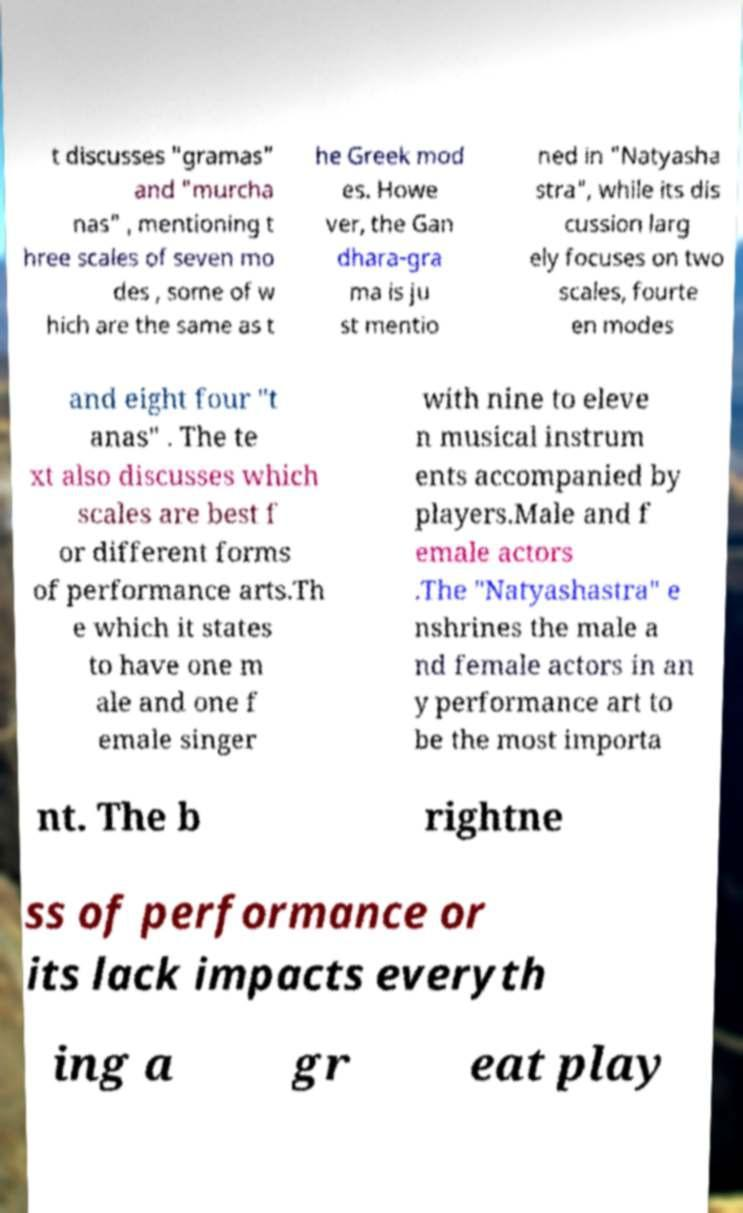Please read and relay the text visible in this image. What does it say? t discusses "gramas" and "murcha nas" , mentioning t hree scales of seven mo des , some of w hich are the same as t he Greek mod es. Howe ver, the Gan dhara-gra ma is ju st mentio ned in "Natyasha stra", while its dis cussion larg ely focuses on two scales, fourte en modes and eight four "t anas" . The te xt also discusses which scales are best f or different forms of performance arts.Th e which it states to have one m ale and one f emale singer with nine to eleve n musical instrum ents accompanied by players.Male and f emale actors .The "Natyashastra" e nshrines the male a nd female actors in an y performance art to be the most importa nt. The b rightne ss of performance or its lack impacts everyth ing a gr eat play 